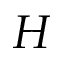Convert formula to latex. <formula><loc_0><loc_0><loc_500><loc_500>H</formula> 